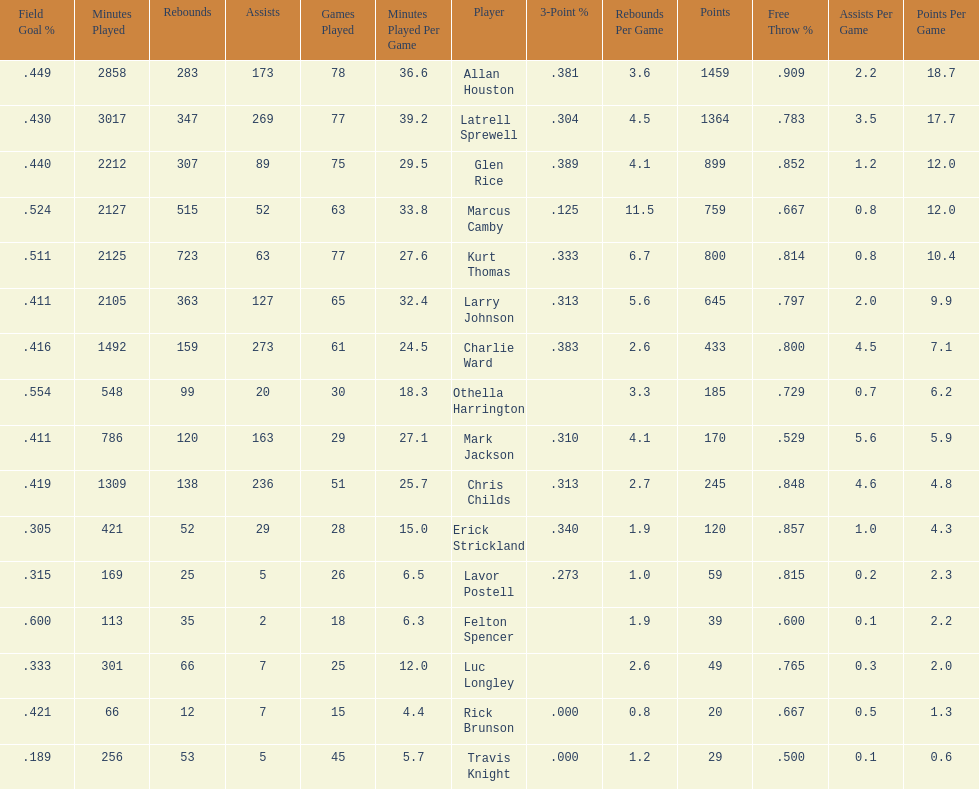How many total points were scored by players averaging over 4 assists per game> 848. 